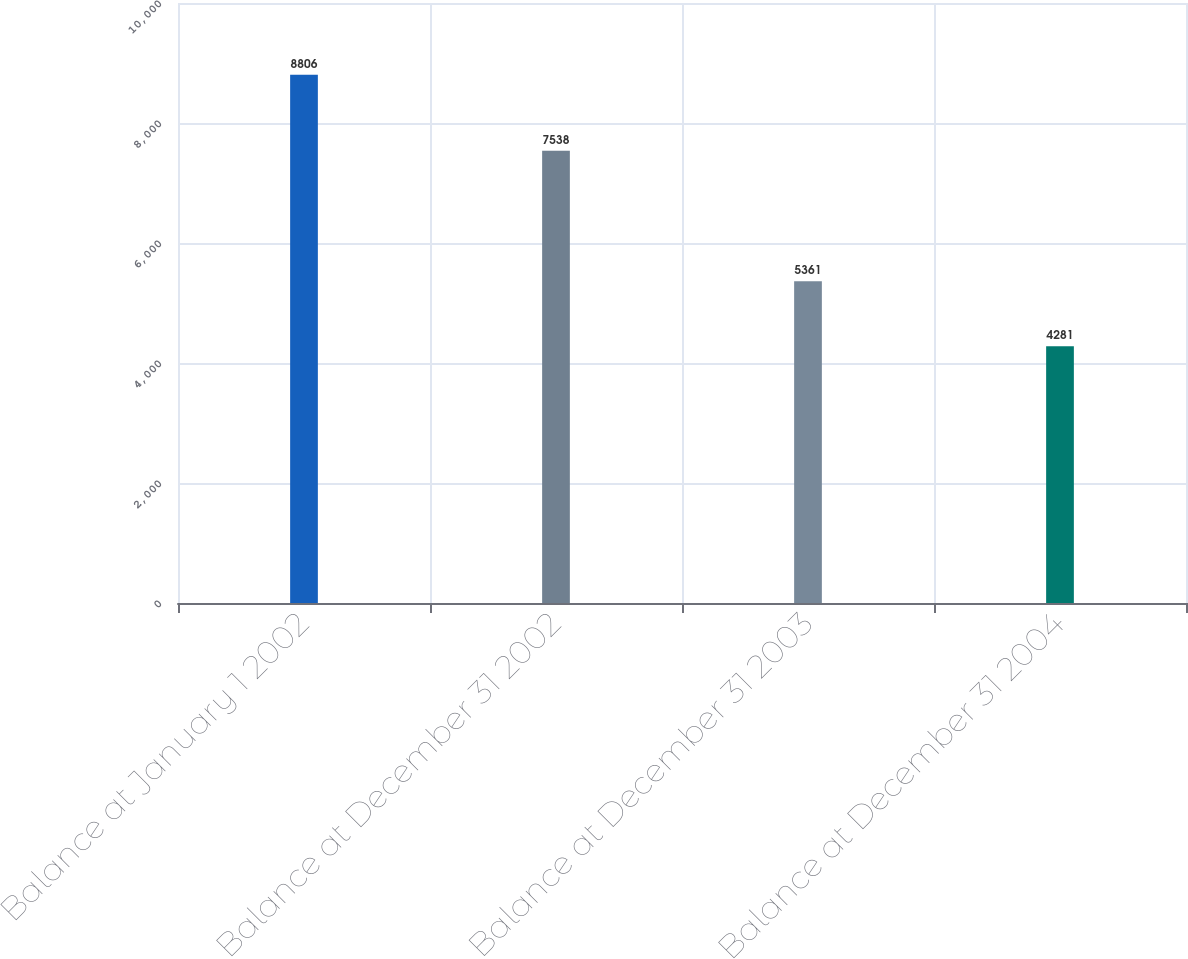Convert chart. <chart><loc_0><loc_0><loc_500><loc_500><bar_chart><fcel>Balance at January 1 2002<fcel>Balance at December 31 2002<fcel>Balance at December 31 2003<fcel>Balance at December 31 2004<nl><fcel>8806<fcel>7538<fcel>5361<fcel>4281<nl></chart> 